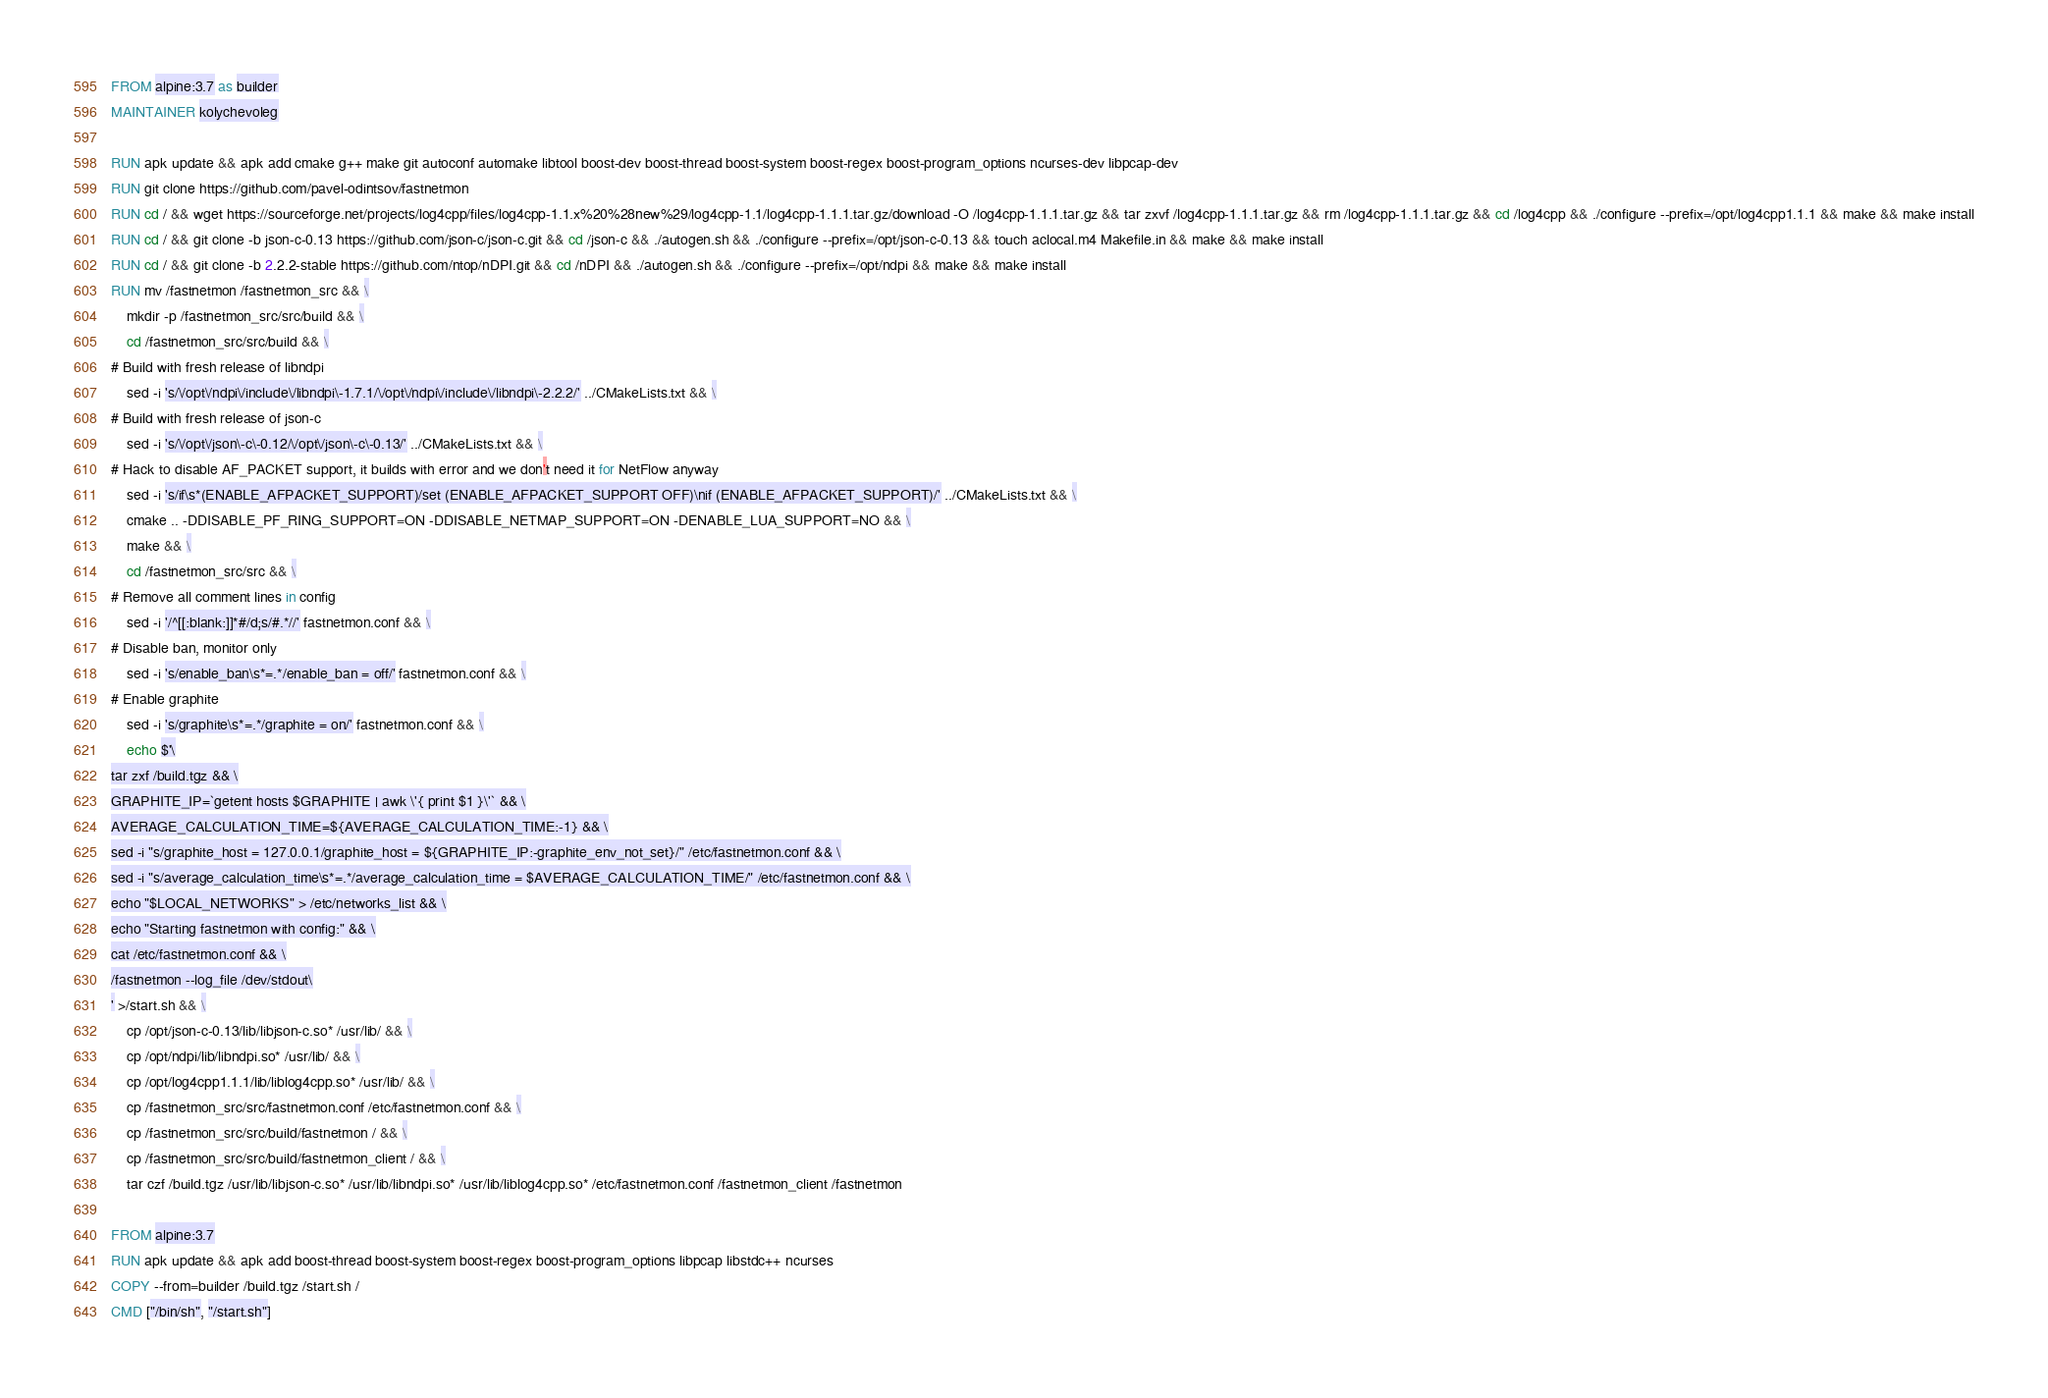<code> <loc_0><loc_0><loc_500><loc_500><_Dockerfile_>FROM alpine:3.7 as builder
MAINTAINER kolychevoleg

RUN apk update && apk add cmake g++ make git autoconf automake libtool boost-dev boost-thread boost-system boost-regex boost-program_options ncurses-dev libpcap-dev
RUN git clone https://github.com/pavel-odintsov/fastnetmon
RUN cd / && wget https://sourceforge.net/projects/log4cpp/files/log4cpp-1.1.x%20%28new%29/log4cpp-1.1/log4cpp-1.1.1.tar.gz/download -O /log4cpp-1.1.1.tar.gz && tar zxvf /log4cpp-1.1.1.tar.gz && rm /log4cpp-1.1.1.tar.gz && cd /log4cpp && ./configure --prefix=/opt/log4cpp1.1.1 && make && make install
RUN cd / && git clone -b json-c-0.13 https://github.com/json-c/json-c.git && cd /json-c && ./autogen.sh && ./configure --prefix=/opt/json-c-0.13 && touch aclocal.m4 Makefile.in && make && make install
RUN cd / && git clone -b 2.2.2-stable https://github.com/ntop/nDPI.git && cd /nDPI && ./autogen.sh && ./configure --prefix=/opt/ndpi && make && make install
RUN mv /fastnetmon /fastnetmon_src && \
    mkdir -p /fastnetmon_src/src/build && \
    cd /fastnetmon_src/src/build && \
# Build with fresh release of libndpi
    sed -i 's/\/opt\/ndpi\/include\/libndpi\-1.7.1/\/opt\/ndpi\/include\/libndpi\-2.2.2/' ../CMakeLists.txt && \
# Build with fresh release of json-c
    sed -i 's/\/opt\/json\-c\-0.12/\/opt\/json\-c\-0.13/' ../CMakeLists.txt && \
# Hack to disable AF_PACKET support, it builds with error and we don't need it for NetFlow anyway
    sed -i 's/if\s*(ENABLE_AFPACKET_SUPPORT)/set (ENABLE_AFPACKET_SUPPORT OFF)\nif (ENABLE_AFPACKET_SUPPORT)/' ../CMakeLists.txt && \
    cmake .. -DDISABLE_PF_RING_SUPPORT=ON -DDISABLE_NETMAP_SUPPORT=ON -DENABLE_LUA_SUPPORT=NO && \
    make && \
    cd /fastnetmon_src/src && \
# Remove all comment lines in config
    sed -i '/^[[:blank:]]*#/d;s/#.*//' fastnetmon.conf && \
# Disable ban, monitor only
    sed -i 's/enable_ban\s*=.*/enable_ban = off/' fastnetmon.conf && \
# Enable graphite
    sed -i 's/graphite\s*=.*/graphite = on/' fastnetmon.conf && \
    echo $'\
tar zxf /build.tgz && \
GRAPHITE_IP=`getent hosts $GRAPHITE | awk \'{ print $1 }\'` && \
AVERAGE_CALCULATION_TIME=${AVERAGE_CALCULATION_TIME:-1} && \
sed -i "s/graphite_host = 127.0.0.1/graphite_host = ${GRAPHITE_IP:-graphite_env_not_set}/" /etc/fastnetmon.conf && \
sed -i "s/average_calculation_time\s*=.*/average_calculation_time = $AVERAGE_CALCULATION_TIME/" /etc/fastnetmon.conf && \
echo "$LOCAL_NETWORKS" > /etc/networks_list && \
echo "Starting fastnetmon with config:" && \
cat /etc/fastnetmon.conf && \
/fastnetmon --log_file /dev/stdout\
' >/start.sh && \
    cp /opt/json-c-0.13/lib/libjson-c.so* /usr/lib/ && \
    cp /opt/ndpi/lib/libndpi.so* /usr/lib/ && \
    cp /opt/log4cpp1.1.1/lib/liblog4cpp.so* /usr/lib/ && \
    cp /fastnetmon_src/src/fastnetmon.conf /etc/fastnetmon.conf && \
    cp /fastnetmon_src/src/build/fastnetmon / && \
    cp /fastnetmon_src/src/build/fastnetmon_client / && \
    tar czf /build.tgz /usr/lib/libjson-c.so* /usr/lib/libndpi.so* /usr/lib/liblog4cpp.so* /etc/fastnetmon.conf /fastnetmon_client /fastnetmon

FROM alpine:3.7
RUN apk update && apk add boost-thread boost-system boost-regex boost-program_options libpcap libstdc++ ncurses
COPY --from=builder /build.tgz /start.sh /
CMD ["/bin/sh", "/start.sh"]
</code> 